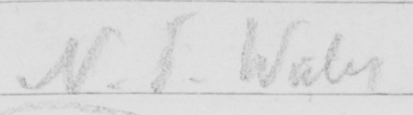What text is written in this handwritten line? N . S . Wales 